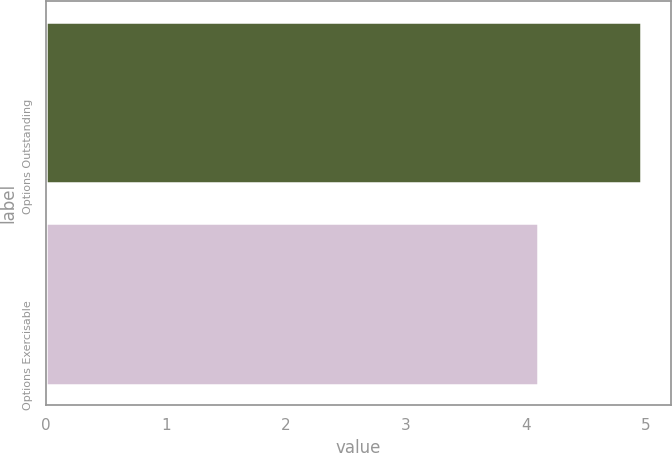<chart> <loc_0><loc_0><loc_500><loc_500><bar_chart><fcel>Options Outstanding<fcel>Options Exercisable<nl><fcel>4.96<fcel>4.1<nl></chart> 